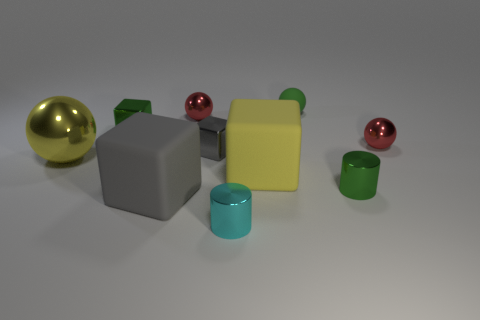Subtract all blue blocks. Subtract all gray spheres. How many blocks are left? 4 Subtract all cylinders. How many objects are left? 8 Subtract all big blue cylinders. Subtract all small spheres. How many objects are left? 7 Add 4 gray cubes. How many gray cubes are left? 6 Add 1 brown shiny cylinders. How many brown shiny cylinders exist? 1 Subtract 0 cyan cubes. How many objects are left? 10 